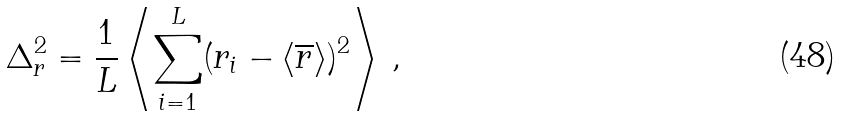<formula> <loc_0><loc_0><loc_500><loc_500>\Delta ^ { 2 } _ { r } = \frac { 1 } { L } \left < \sum _ { i = 1 } ^ { L } ( { r } _ { i } - \left < \overline { r } \right > ) ^ { 2 } \right > \, ,</formula> 